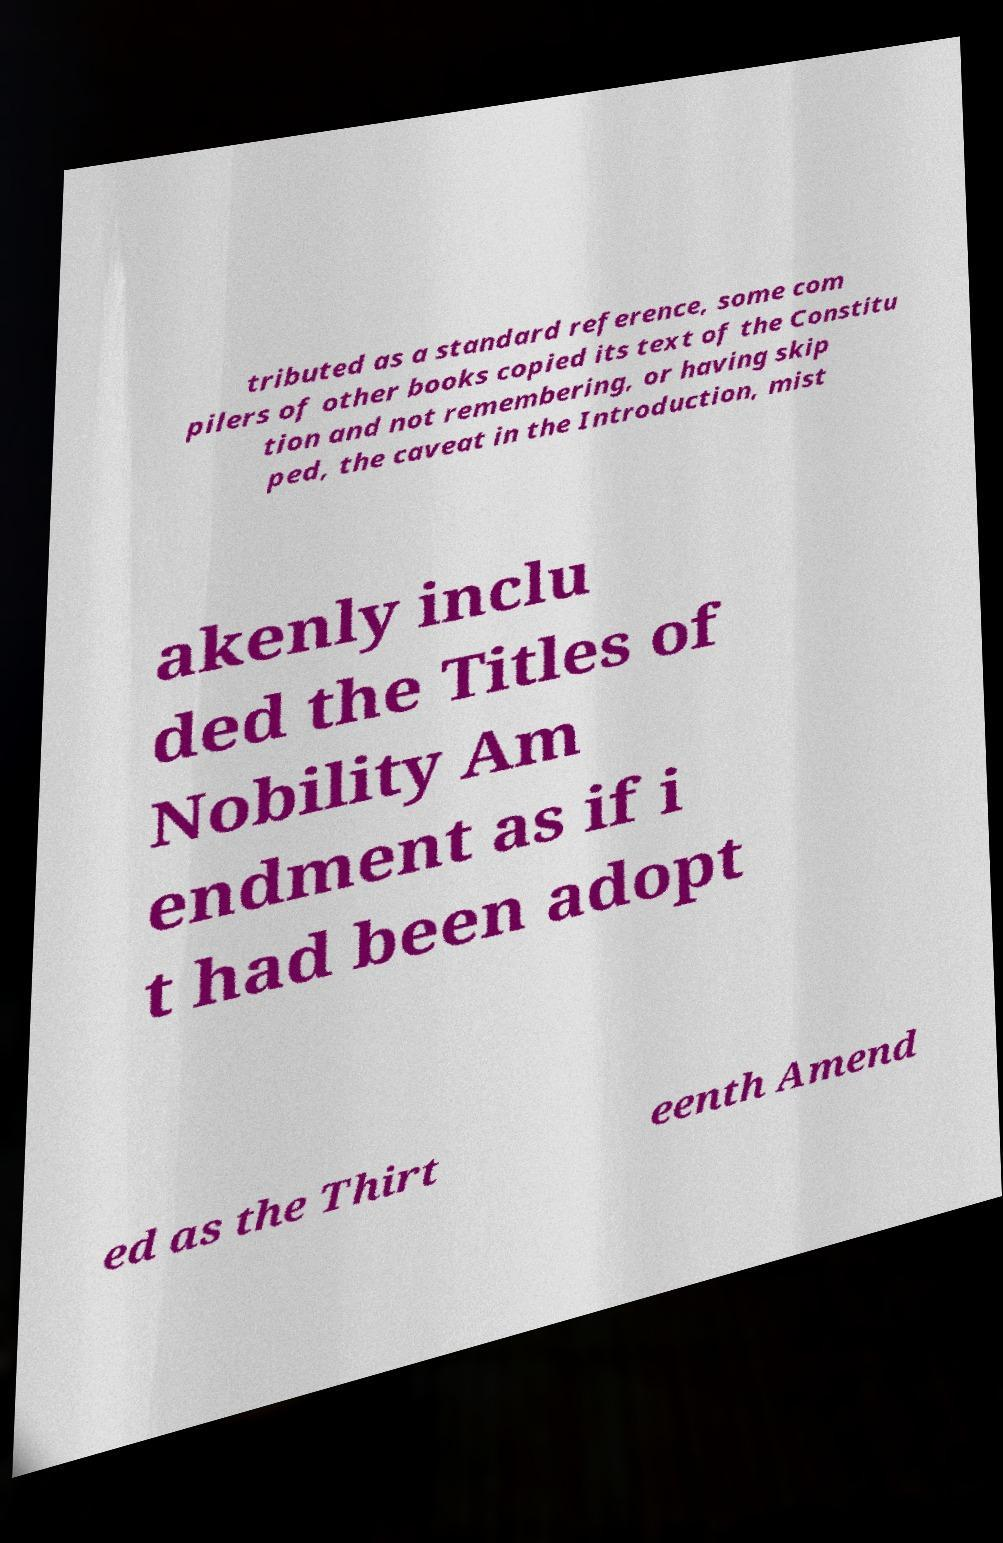I need the written content from this picture converted into text. Can you do that? tributed as a standard reference, some com pilers of other books copied its text of the Constitu tion and not remembering, or having skip ped, the caveat in the Introduction, mist akenly inclu ded the Titles of Nobility Am endment as if i t had been adopt ed as the Thirt eenth Amend 